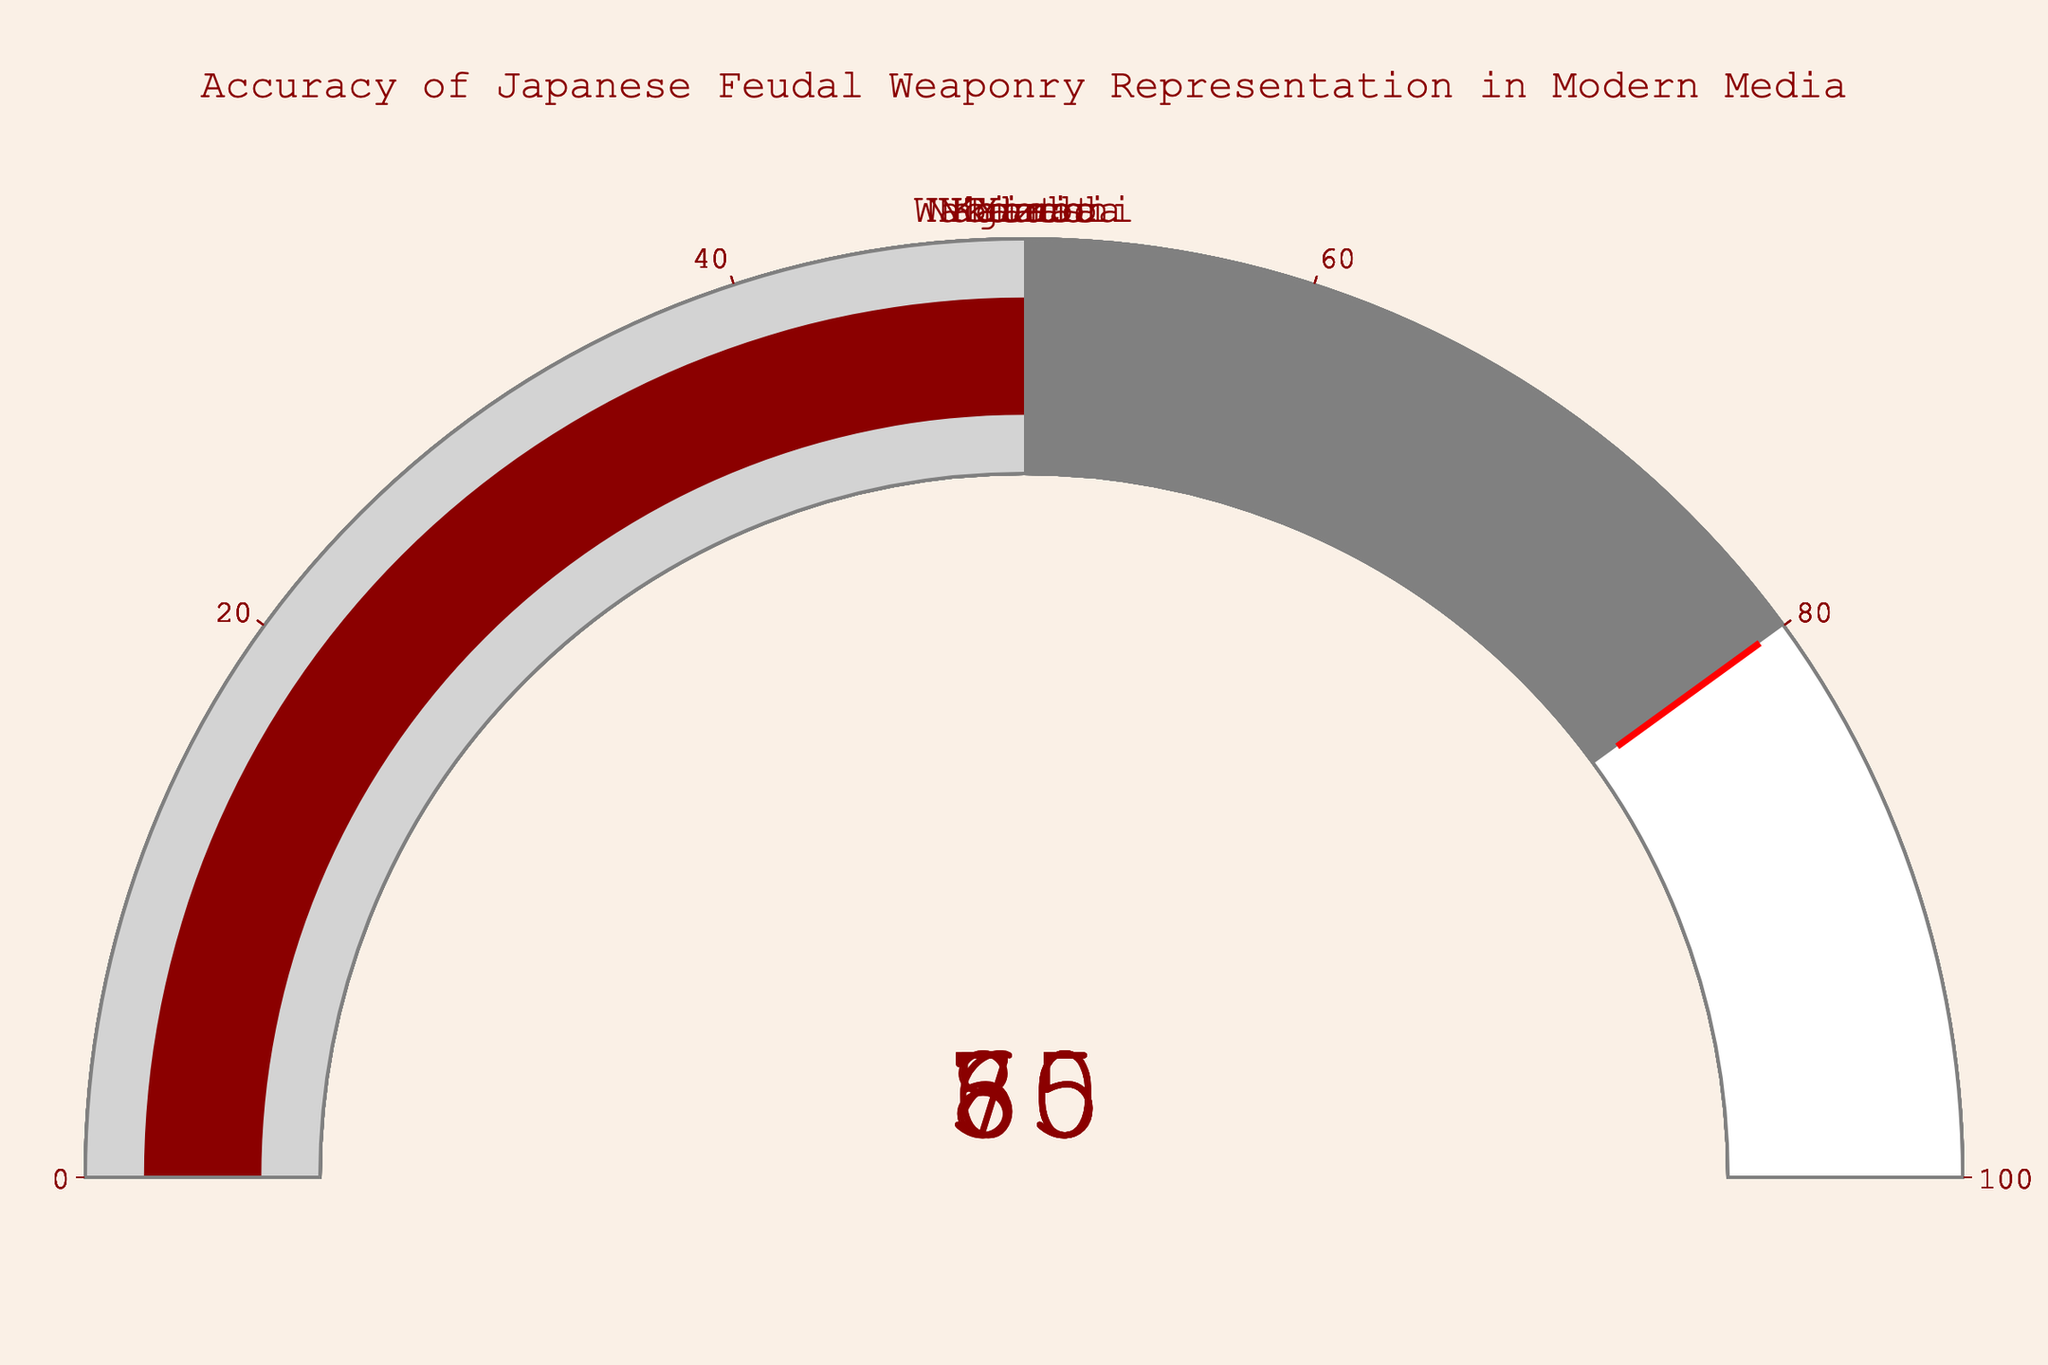How many weapons are shown in the chart? The chart has eight gauges, each representing a different weapon. Hence, there are eight weapons shown in the chart.
Answer: Eight Which weapon has the highest accuracy percentage? By looking at the gauges, the Katana has the highest accuracy percentage at 85%.
Answer: Katana Which weapon has the lowest accuracy percentage? The Nodachi has the lowest accuracy percentage displayed at 50%.
Answer: Nodachi What's the average accuracy percentage of all the weapons? Sum the percentages: 85 (Katana) + 70 (Yari) + 65 (Naginata) + 80 (Wakizashi) + 55 (Kanabo) + 75 (Yumi) + 60 (Tanto) + 50 (Nodachi) = 540. Divide by the number of weapons (8): 540 / 8 = 67.5.
Answer: 67.5 Is the accuracy representation of the Kanabo above or below 60%? The Kanabo has an accuracy percentage of 55%, which is below 60%.
Answer: Below Which weapon's accuracy percentage is closest to the threshold value used in the gauges? The threshold is set at 80%. The Wakizashi has an accuracy percentage of 80%, which is exactly at the threshold level.
Answer: Wakizashi How many weapons have an accuracy percentage greater than or equal to 70%? Weapons with percentages >= 70% are Katana (85%), Yari (70%), Wakizashi (80%), and Yumi (75%). Four weapons in total.
Answer: Four What's the difference in accuracy percentage between Katana and Kanabo? The Katana has 85% and the Kanabo has 55% accuracy. The difference is 85 - 55 = 30%.
Answer: 30% Which weapons have an accuracy percentage within the range of 60% to 70% inclusive? Weapons in this range are Yari (70%) and Tanto (60%).
Answer: Yari, Tanto What is the median accuracy percentage of the weaponry represented? Order the percentages: 50, 55, 60, 65, 70, 75, 80, 85. The median value is the average of the middle two values: (65 + 70) / 2 = 67.5.
Answer: 67.5 